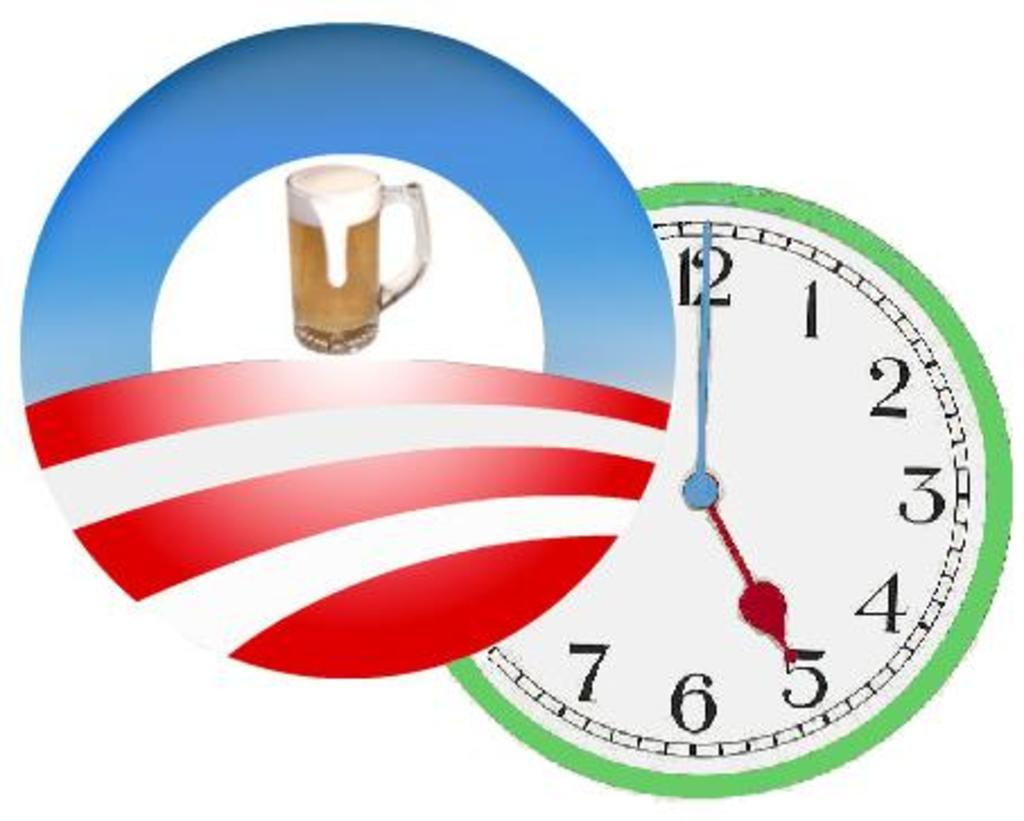<image>
Offer a succinct explanation of the picture presented. A clock with numbers 1-7 and 12 against a white backdrop. 